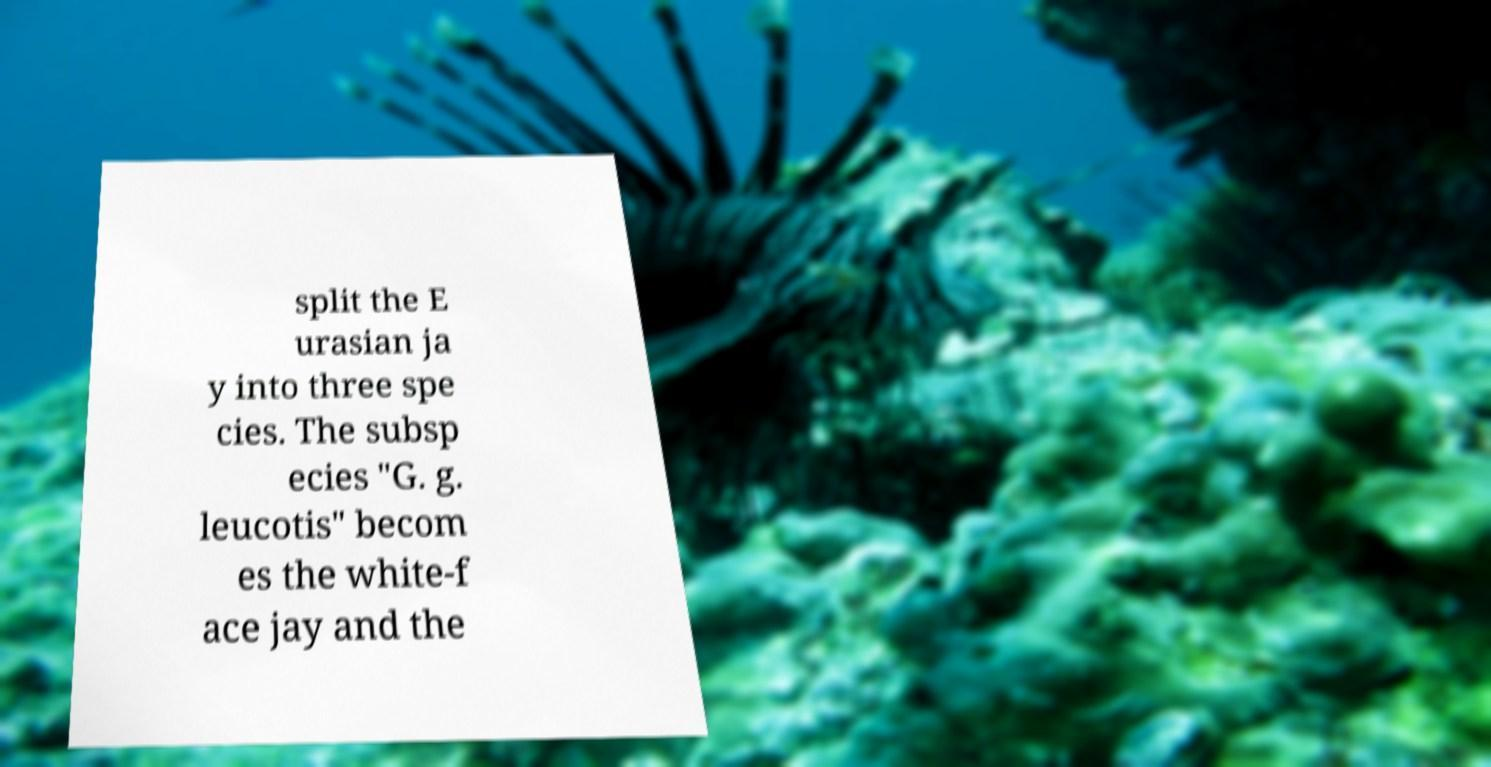Please identify and transcribe the text found in this image. split the E urasian ja y into three spe cies. The subsp ecies "G. g. leucotis" becom es the white-f ace jay and the 